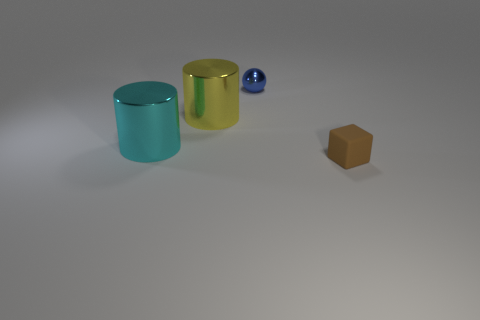There is a matte object that is the same size as the blue metal thing; what shape is it?
Offer a very short reply. Cube. How many objects are metallic things in front of the tiny blue metal sphere or big metallic objects left of the big yellow metal thing?
Ensure brevity in your answer.  2. There is a brown block that is the same size as the blue thing; what material is it?
Offer a very short reply. Rubber. How many other things are there of the same material as the cyan cylinder?
Offer a very short reply. 2. Do the big metal object behind the cyan metal object and the metal thing that is to the left of the large yellow cylinder have the same shape?
Give a very brief answer. Yes. There is a tiny thing behind the object in front of the big shiny cylinder in front of the yellow cylinder; what color is it?
Offer a very short reply. Blue. Are there fewer small brown things than tiny cyan matte spheres?
Ensure brevity in your answer.  No. What is the color of the object that is in front of the yellow cylinder and to the right of the cyan thing?
Your response must be concise. Brown. What material is the other object that is the same shape as the cyan metallic object?
Your answer should be compact. Metal. Is there any other thing that has the same size as the blue metallic sphere?
Keep it short and to the point. Yes. 